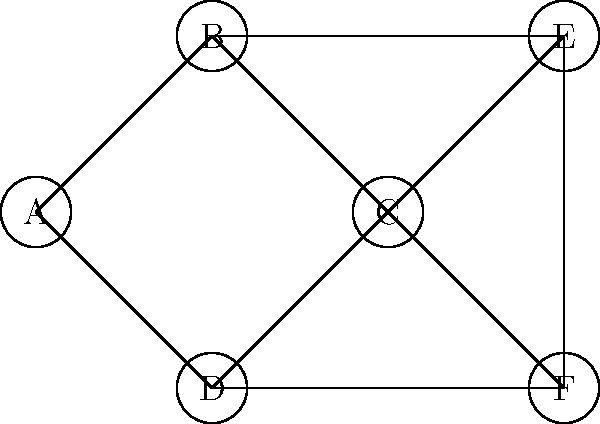In the given planar graph, what is the minimum number of colors needed to color the vertices such that no two adjacent vertices have the same color? Provide your answer and briefly explain your reasoning. To determine the minimum number of colors needed, we can follow these steps:

1. Observe that the graph is planar and has no self-loops or multiple edges.

2. Apply the Four Color Theorem, which states that any planar graph can be colored using at most four colors.

3. However, we need to check if we can color this specific graph with fewer colors:

   a) Start by coloring vertex A with color 1.
   b) Vertices B, C, and D are all adjacent to A, so they must have different colors. Assign colors 2, 3, and 4 to these vertices.
   c) Vertex E is adjacent to B and C, so it must have a different color from both. We can use color 4 for E.
   d) Vertex F is adjacent to C and D, so it must have a different color from both. We can use color 2 for F.

4. We have successfully colored the graph using only 4 colors, and it's not possible to use fewer colors because vertices A, B, C, and D form a complete subgraph (K4) that requires 4 different colors.

Therefore, the minimum number of colors needed is 4.
Answer: 4 colors 